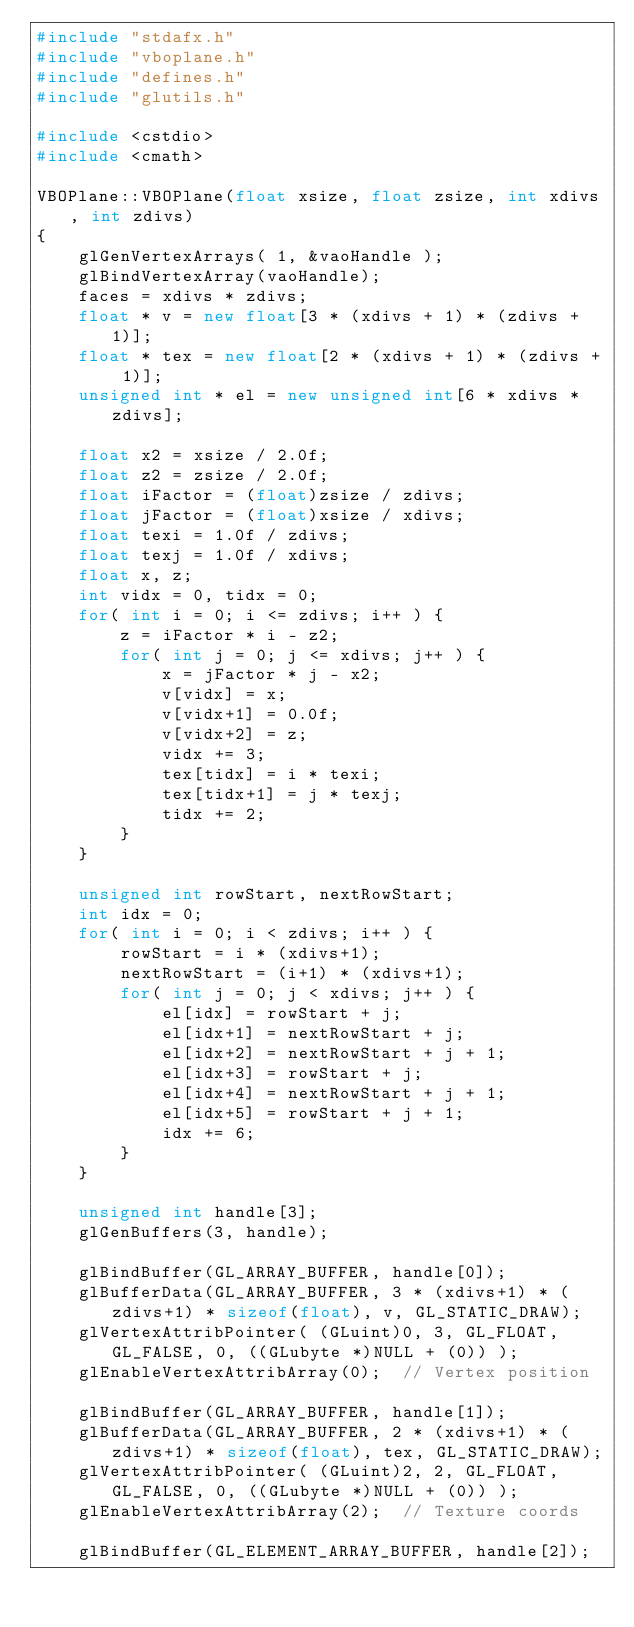<code> <loc_0><loc_0><loc_500><loc_500><_C++_>#include "stdafx.h"
#include "vboplane.h"
#include "defines.h"
#include "glutils.h"

#include <cstdio>
#include <cmath>

VBOPlane::VBOPlane(float xsize, float zsize, int xdivs, int zdivs)
{
    glGenVertexArrays( 1, &vaoHandle );
    glBindVertexArray(vaoHandle);
    faces = xdivs * zdivs;
    float * v = new float[3 * (xdivs + 1) * (zdivs + 1)];
    float * tex = new float[2 * (xdivs + 1) * (zdivs + 1)];
    unsigned int * el = new unsigned int[6 * xdivs * zdivs];

    float x2 = xsize / 2.0f;
    float z2 = zsize / 2.0f;
    float iFactor = (float)zsize / zdivs;
    float jFactor = (float)xsize / xdivs;
    float texi = 1.0f / zdivs;
    float texj = 1.0f / xdivs;
    float x, z;
    int vidx = 0, tidx = 0;
    for( int i = 0; i <= zdivs; i++ ) {
        z = iFactor * i - z2;
        for( int j = 0; j <= xdivs; j++ ) {
            x = jFactor * j - x2;
            v[vidx] = x;
            v[vidx+1] = 0.0f;
            v[vidx+2] = z;
            vidx += 3;
            tex[tidx] = i * texi;
            tex[tidx+1] = j * texj;
            tidx += 2;
        }
    }

    unsigned int rowStart, nextRowStart;
    int idx = 0;
    for( int i = 0; i < zdivs; i++ ) {
        rowStart = i * (xdivs+1);
        nextRowStart = (i+1) * (xdivs+1);
        for( int j = 0; j < xdivs; j++ ) {
            el[idx] = rowStart + j;
            el[idx+1] = nextRowStart + j;
            el[idx+2] = nextRowStart + j + 1;
            el[idx+3] = rowStart + j;
            el[idx+4] = nextRowStart + j + 1;
            el[idx+5] = rowStart + j + 1;
            idx += 6;
        }
    }

    unsigned int handle[3];
    glGenBuffers(3, handle);

    glBindBuffer(GL_ARRAY_BUFFER, handle[0]);
    glBufferData(GL_ARRAY_BUFFER, 3 * (xdivs+1) * (zdivs+1) * sizeof(float), v, GL_STATIC_DRAW);
    glVertexAttribPointer( (GLuint)0, 3, GL_FLOAT, GL_FALSE, 0, ((GLubyte *)NULL + (0)) );
    glEnableVertexAttribArray(0);  // Vertex position

    glBindBuffer(GL_ARRAY_BUFFER, handle[1]);
    glBufferData(GL_ARRAY_BUFFER, 2 * (xdivs+1) * (zdivs+1) * sizeof(float), tex, GL_STATIC_DRAW);
    glVertexAttribPointer( (GLuint)2, 2, GL_FLOAT, GL_FALSE, 0, ((GLubyte *)NULL + (0)) );
    glEnableVertexAttribArray(2);  // Texture coords

    glBindBuffer(GL_ELEMENT_ARRAY_BUFFER, handle[2]);</code> 